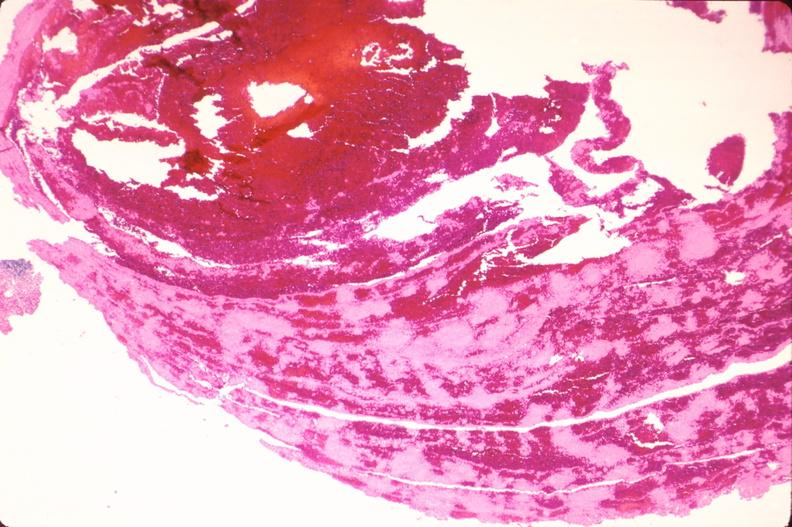what is present?
Answer the question using a single word or phrase. Cardiovascular 